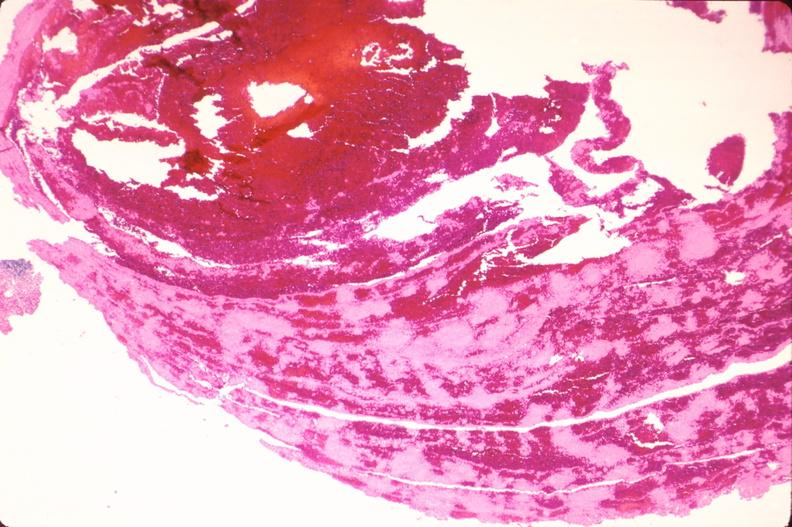what is present?
Answer the question using a single word or phrase. Cardiovascular 